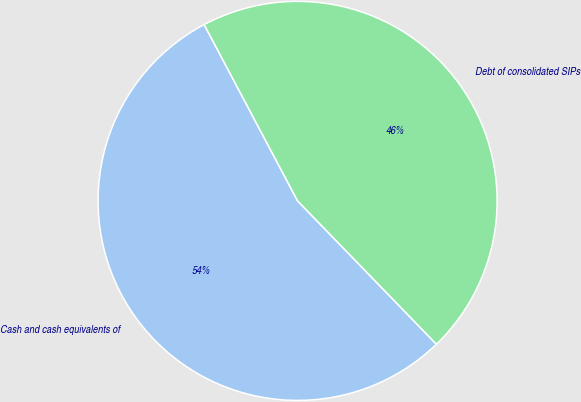<chart> <loc_0><loc_0><loc_500><loc_500><pie_chart><fcel>Cash and cash equivalents of<fcel>Debt of consolidated SIPs<nl><fcel>54.49%<fcel>45.51%<nl></chart> 